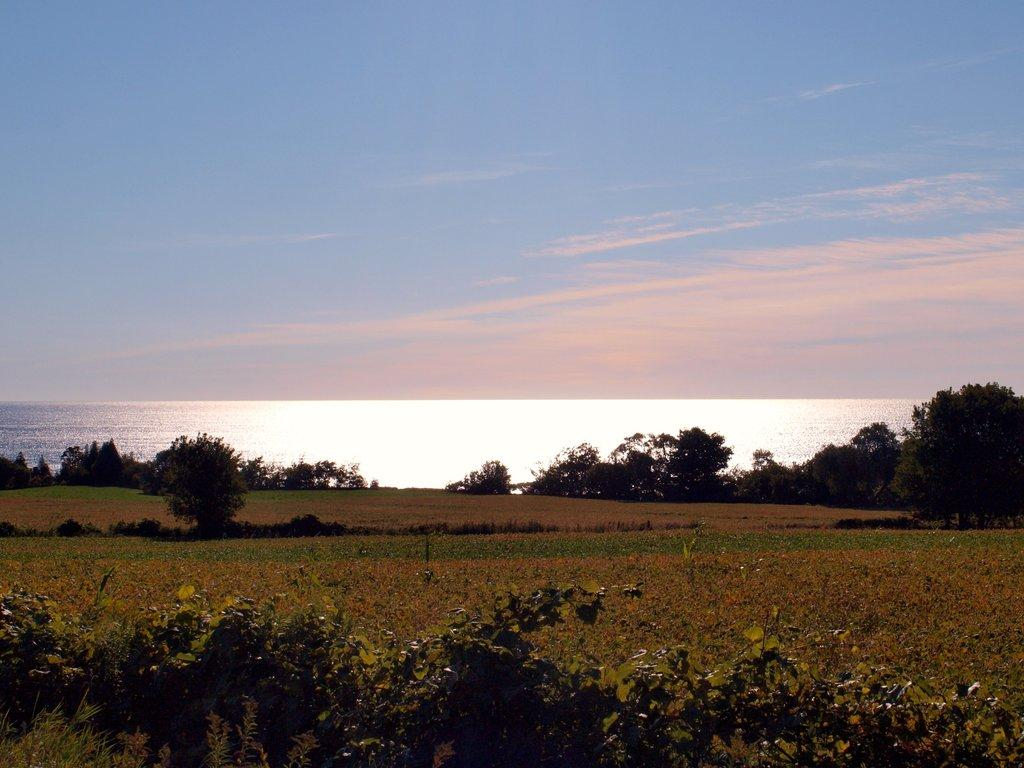What is located in the center of the image? There are trees in the center of the image. What else can be seen in the image besides trees? There is water and the ground visible in the image. How is the ground depicted in the image? Some parts of the ground are covered with plants. What is visible at the top of the image? The sky is visible at the top of the image. What type of pancake can be heard in the image? There is no pancake present in the image, and therefore no sound can be heard from it. 